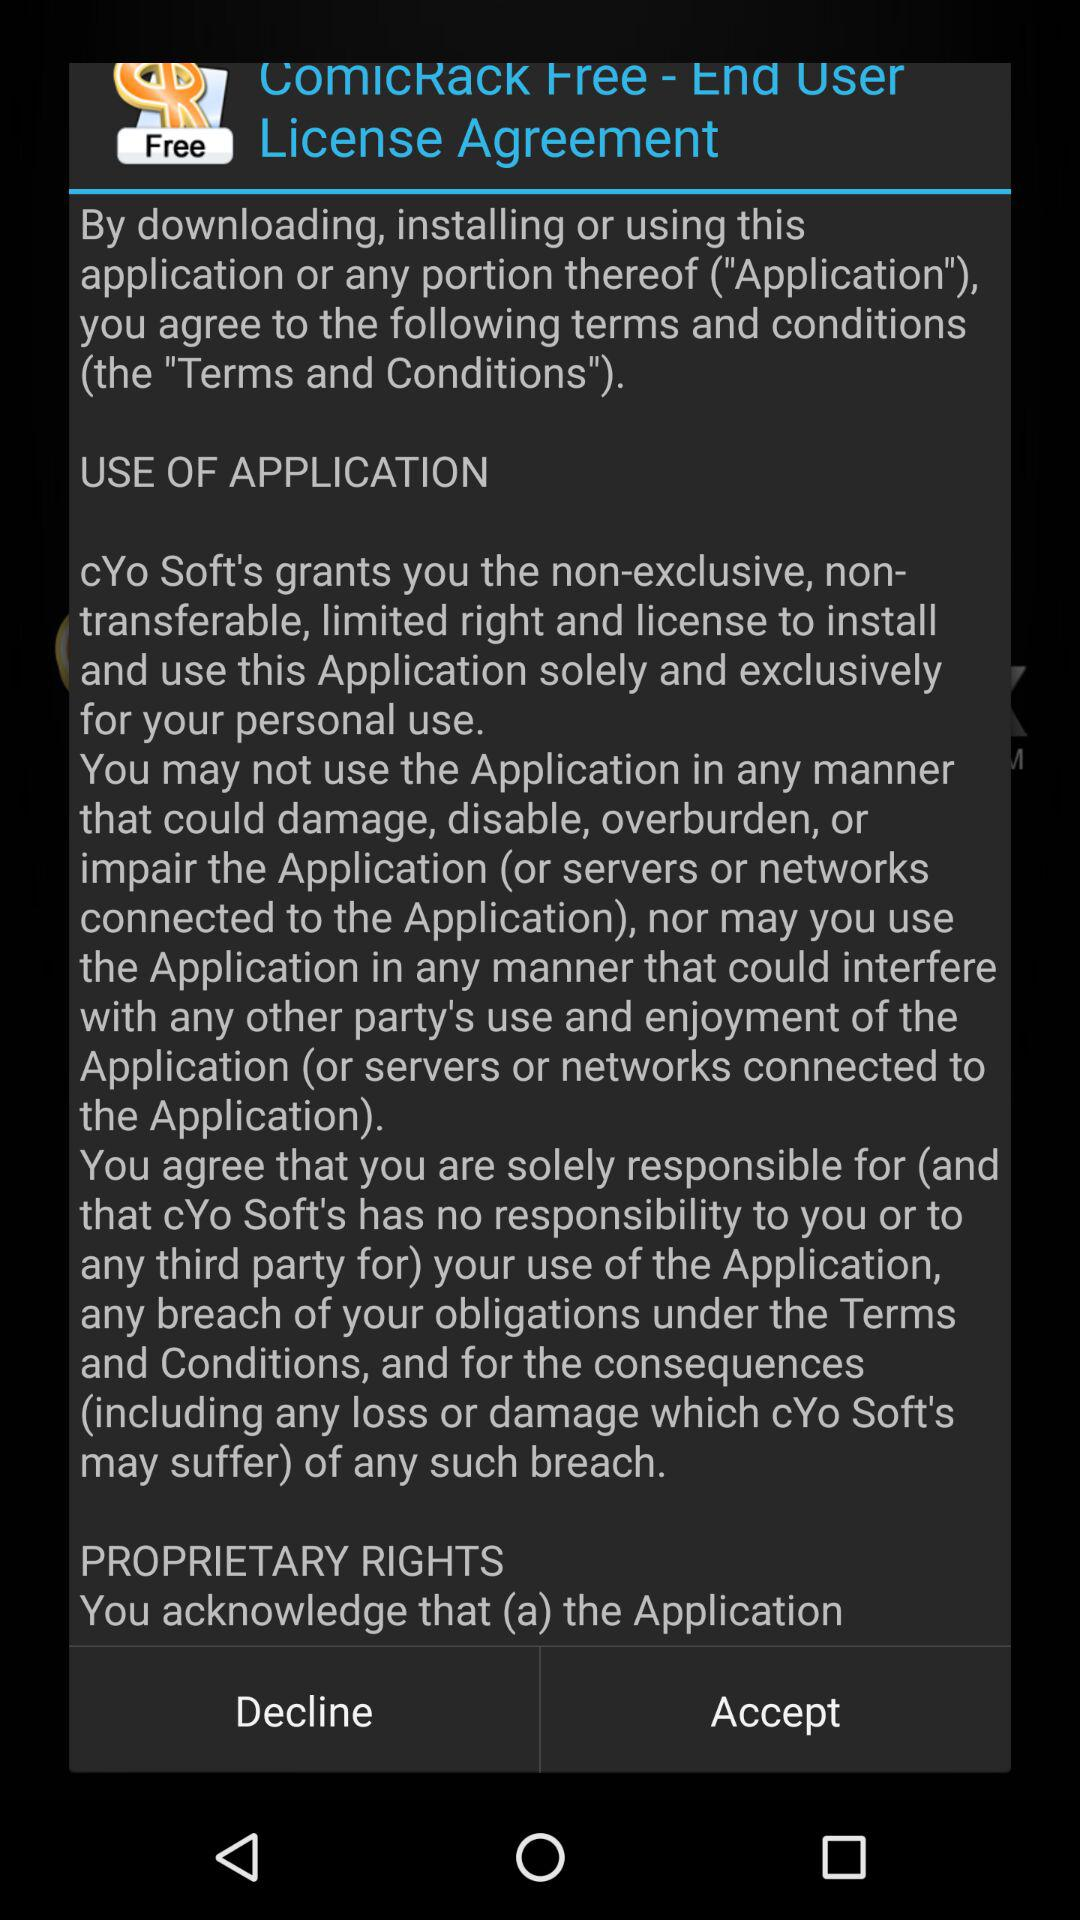What is the name of the application? The name of the application is "ComicRack Free". 